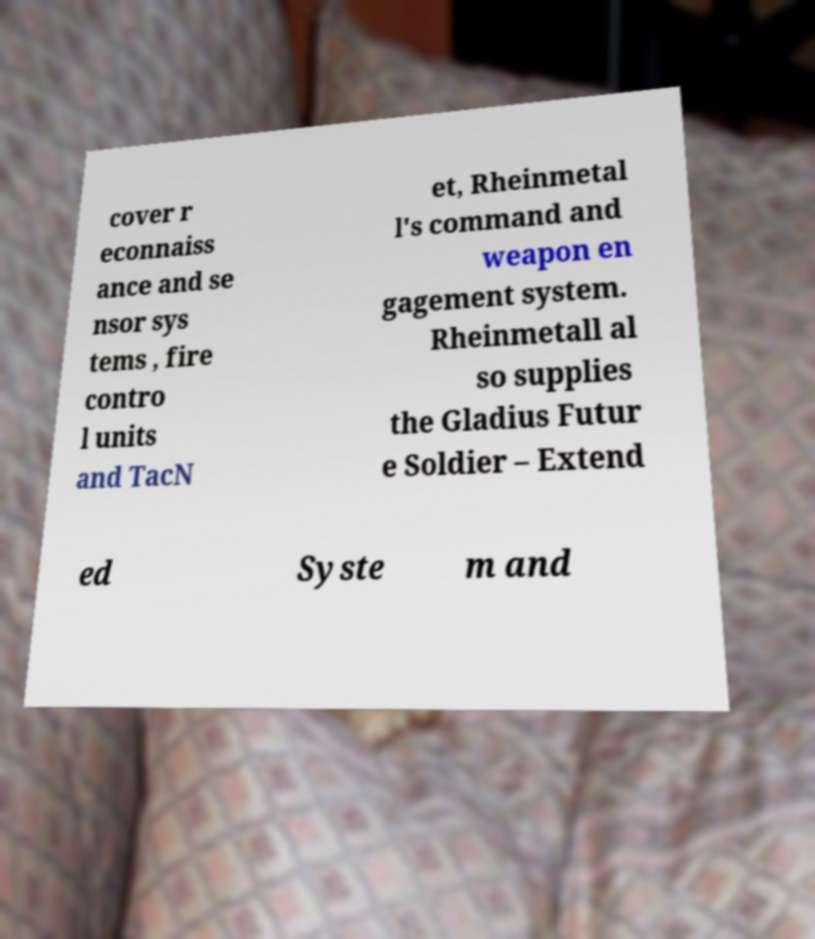Could you assist in decoding the text presented in this image and type it out clearly? cover r econnaiss ance and se nsor sys tems , fire contro l units and TacN et, Rheinmetal l's command and weapon en gagement system. Rheinmetall al so supplies the Gladius Futur e Soldier – Extend ed Syste m and 